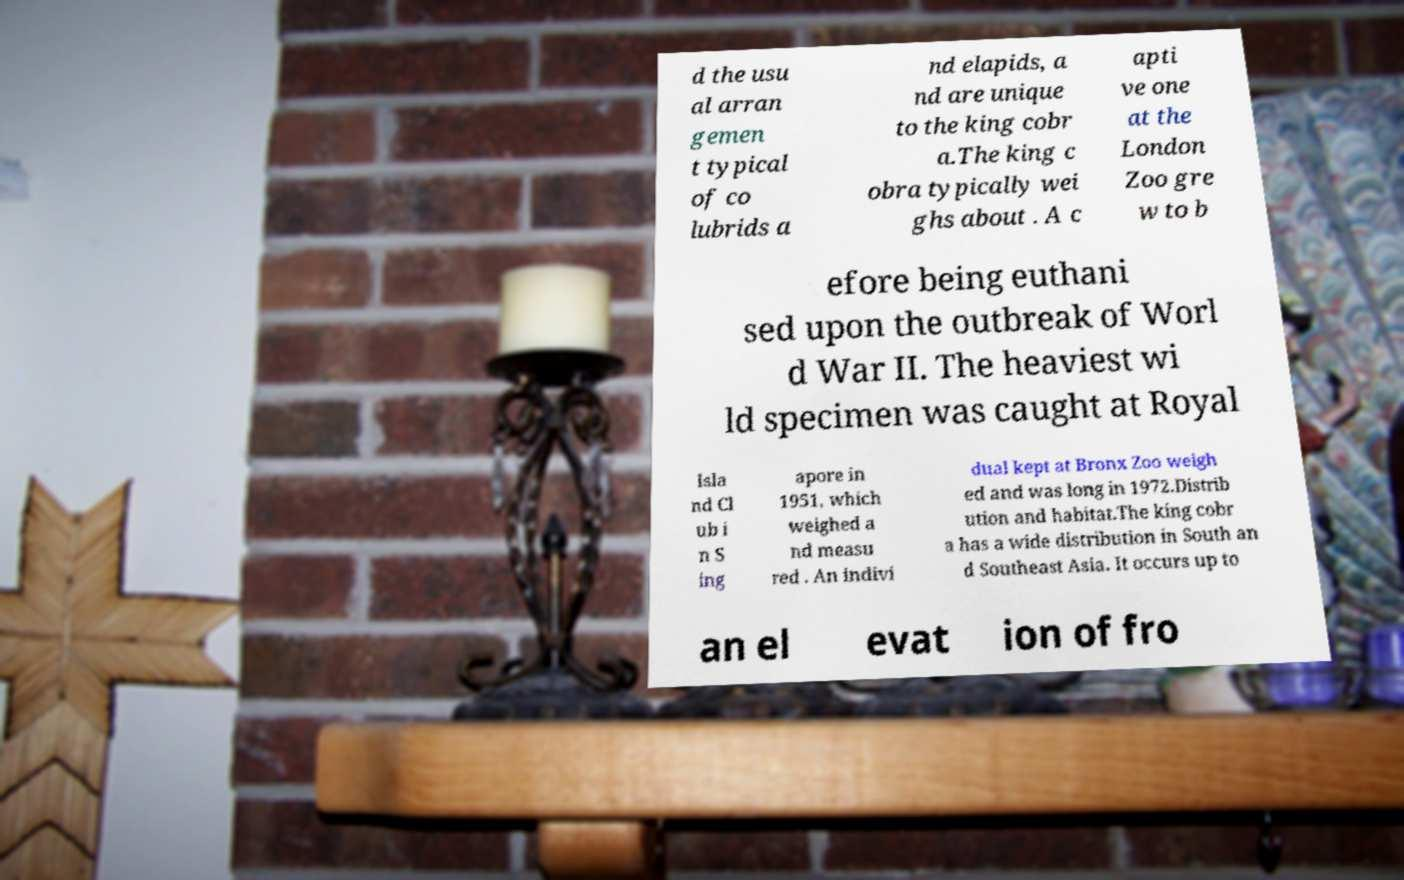Can you accurately transcribe the text from the provided image for me? d the usu al arran gemen t typical of co lubrids a nd elapids, a nd are unique to the king cobr a.The king c obra typically wei ghs about . A c apti ve one at the London Zoo gre w to b efore being euthani sed upon the outbreak of Worl d War II. The heaviest wi ld specimen was caught at Royal Isla nd Cl ub i n S ing apore in 1951, which weighed a nd measu red . An indivi dual kept at Bronx Zoo weigh ed and was long in 1972.Distrib ution and habitat.The king cobr a has a wide distribution in South an d Southeast Asia. It occurs up to an el evat ion of fro 